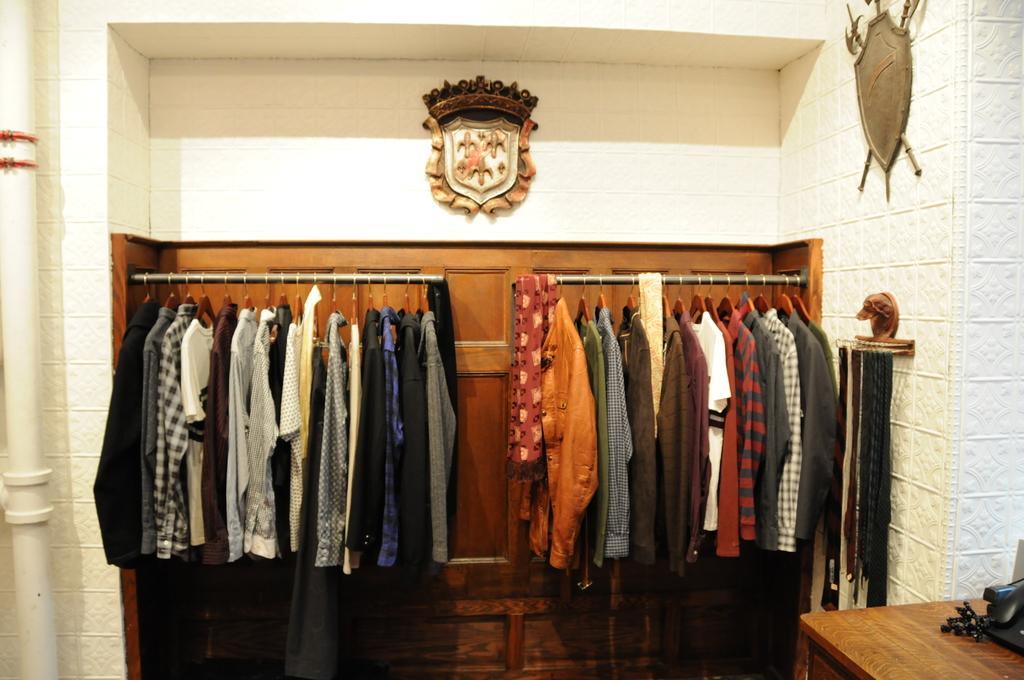Could you give a brief overview of what you see in this image? This is image was taken in a room. There is a closet filled with different kinds of shirts in different colors. There are two antique pieces hanging to a wall. To the left corner there is a pipe. To the right bottom there is a table. There are some belts hanging to the wall. 